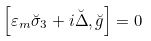<formula> <loc_0><loc_0><loc_500><loc_500>\left [ \varepsilon _ { m } \breve { \sigma } _ { 3 } + i \breve { \Delta } , \breve { g } \right ] = 0</formula> 